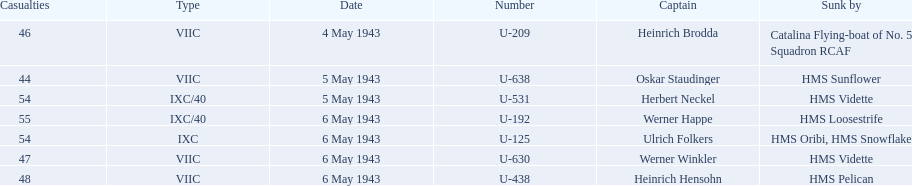What is the only vessel to sink multiple u-boats? HMS Vidette. 